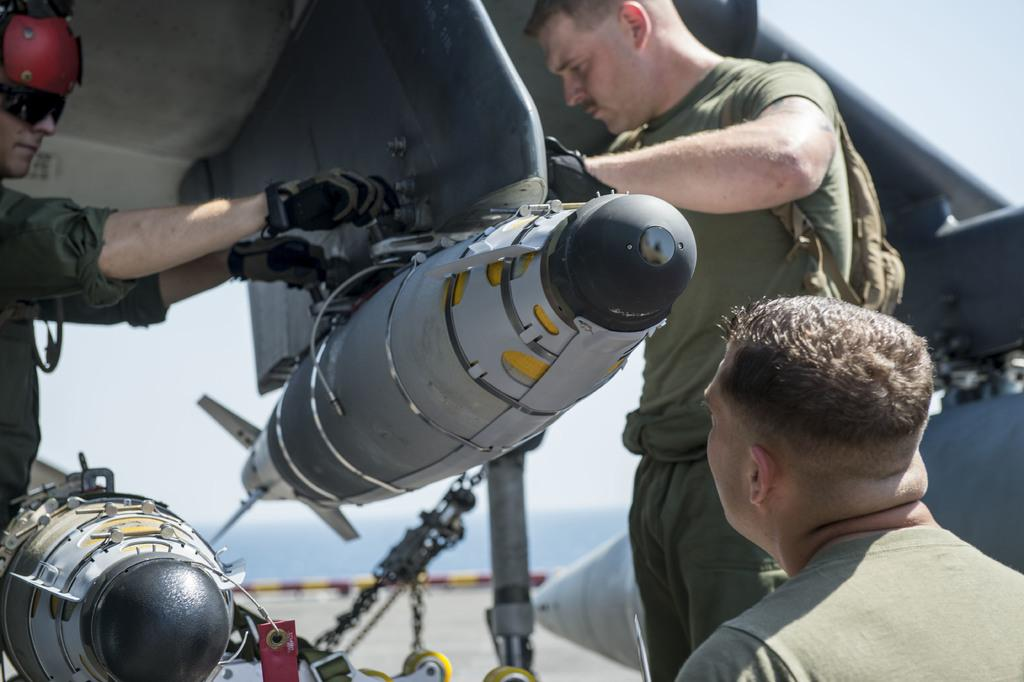What is located in the foreground of the image? There is a vehicle and three persons in the foreground of the image. What can be seen on the road in the foreground of the image? There are objects on the road in the foreground of the image. What is visible in the background of the image? Mountains and the sky are visible in the background of the image. Can you describe the time of day when the image was taken? The image appears to be taken during the day. How many times does the person in the middle sneeze in the image? There is no indication of anyone sneezing in the image. What is the person in the foreground thinking about in the image? The image does not provide any information about the person's thoughts or mental state. 